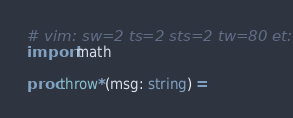Convert code to text. <code><loc_0><loc_0><loc_500><loc_500><_Nim_># vim: sw=2 ts=2 sts=2 tw=80 et:
import math

proc throw*(msg: string) =</code> 